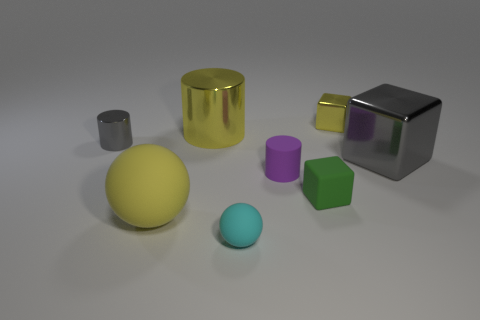Add 2 small cyan rubber objects. How many objects exist? 10 Subtract all purple blocks. Subtract all brown balls. How many blocks are left? 3 Subtract all cylinders. How many objects are left? 5 Add 7 tiny gray metal things. How many tiny gray metal things exist? 8 Subtract 0 green spheres. How many objects are left? 8 Subtract all cyan rubber objects. Subtract all gray metal cylinders. How many objects are left? 6 Add 3 green blocks. How many green blocks are left? 4 